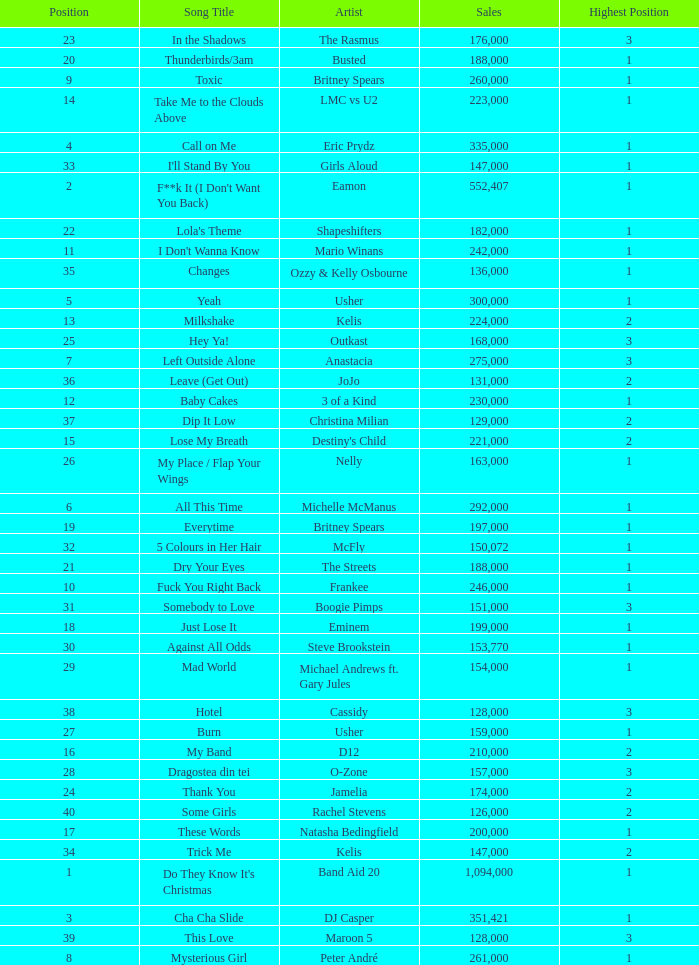What is the most sales by a song with a position higher than 3? None. 